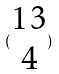Convert formula to latex. <formula><loc_0><loc_0><loc_500><loc_500>( \begin{matrix} 1 3 \\ 4 \end{matrix} )</formula> 